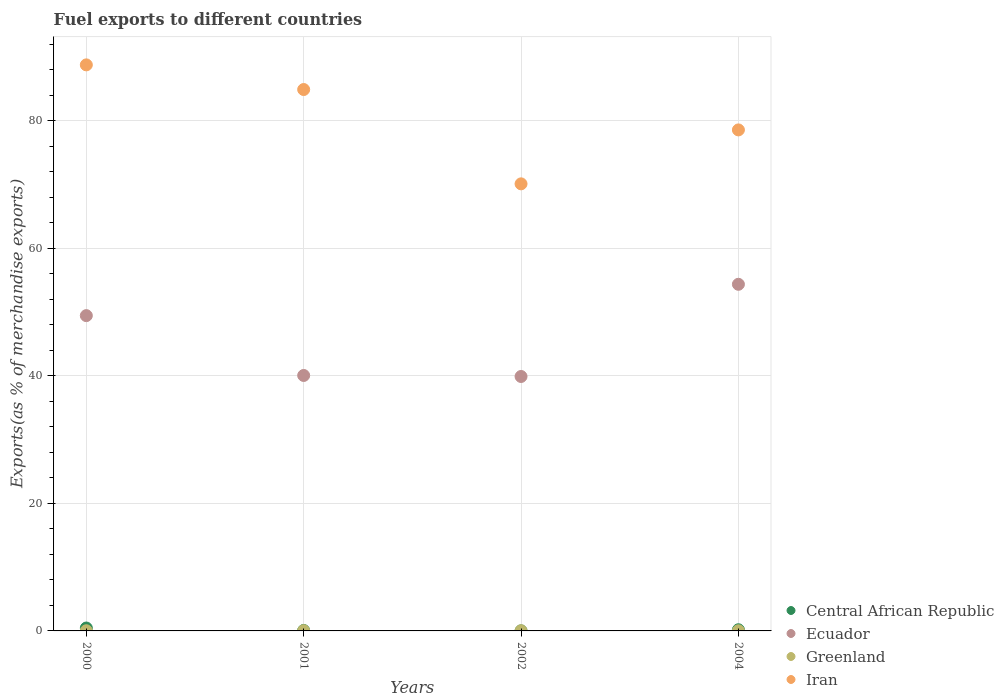How many different coloured dotlines are there?
Keep it short and to the point. 4. Is the number of dotlines equal to the number of legend labels?
Your response must be concise. Yes. What is the percentage of exports to different countries in Ecuador in 2004?
Make the answer very short. 54.34. Across all years, what is the maximum percentage of exports to different countries in Central African Republic?
Provide a succinct answer. 0.45. Across all years, what is the minimum percentage of exports to different countries in Ecuador?
Keep it short and to the point. 39.89. What is the total percentage of exports to different countries in Central African Republic in the graph?
Give a very brief answer. 0.72. What is the difference between the percentage of exports to different countries in Central African Republic in 2000 and that in 2002?
Make the answer very short. 0.45. What is the difference between the percentage of exports to different countries in Ecuador in 2002 and the percentage of exports to different countries in Iran in 2000?
Give a very brief answer. -48.85. What is the average percentage of exports to different countries in Ecuador per year?
Provide a succinct answer. 45.93. In the year 2000, what is the difference between the percentage of exports to different countries in Iran and percentage of exports to different countries in Central African Republic?
Keep it short and to the point. 88.29. What is the ratio of the percentage of exports to different countries in Ecuador in 2001 to that in 2004?
Give a very brief answer. 0.74. Is the percentage of exports to different countries in Iran in 2001 less than that in 2002?
Provide a succinct answer. No. Is the difference between the percentage of exports to different countries in Iran in 2000 and 2004 greater than the difference between the percentage of exports to different countries in Central African Republic in 2000 and 2004?
Your answer should be very brief. Yes. What is the difference between the highest and the second highest percentage of exports to different countries in Iran?
Offer a terse response. 3.86. What is the difference between the highest and the lowest percentage of exports to different countries in Ecuador?
Make the answer very short. 14.45. In how many years, is the percentage of exports to different countries in Central African Republic greater than the average percentage of exports to different countries in Central African Republic taken over all years?
Make the answer very short. 2. Is it the case that in every year, the sum of the percentage of exports to different countries in Iran and percentage of exports to different countries in Central African Republic  is greater than the sum of percentage of exports to different countries in Ecuador and percentage of exports to different countries in Greenland?
Your response must be concise. Yes. Does the percentage of exports to different countries in Ecuador monotonically increase over the years?
Provide a short and direct response. No. Is the percentage of exports to different countries in Central African Republic strictly less than the percentage of exports to different countries in Iran over the years?
Your answer should be compact. Yes. How many years are there in the graph?
Your answer should be very brief. 4. Does the graph contain any zero values?
Provide a short and direct response. No. Where does the legend appear in the graph?
Offer a very short reply. Bottom right. How many legend labels are there?
Provide a succinct answer. 4. What is the title of the graph?
Your response must be concise. Fuel exports to different countries. Does "Sub-Saharan Africa (developing only)" appear as one of the legend labels in the graph?
Your answer should be very brief. No. What is the label or title of the Y-axis?
Your response must be concise. Exports(as % of merchandise exports). What is the Exports(as % of merchandise exports) of Central African Republic in 2000?
Keep it short and to the point. 0.45. What is the Exports(as % of merchandise exports) in Ecuador in 2000?
Offer a very short reply. 49.43. What is the Exports(as % of merchandise exports) of Greenland in 2000?
Ensure brevity in your answer.  0.03. What is the Exports(as % of merchandise exports) of Iran in 2000?
Make the answer very short. 88.74. What is the Exports(as % of merchandise exports) of Central African Republic in 2001?
Offer a very short reply. 0.08. What is the Exports(as % of merchandise exports) in Ecuador in 2001?
Provide a succinct answer. 40.05. What is the Exports(as % of merchandise exports) in Greenland in 2001?
Give a very brief answer. 0.04. What is the Exports(as % of merchandise exports) of Iran in 2001?
Offer a terse response. 84.88. What is the Exports(as % of merchandise exports) of Central African Republic in 2002?
Offer a terse response. 0.01. What is the Exports(as % of merchandise exports) of Ecuador in 2002?
Your response must be concise. 39.89. What is the Exports(as % of merchandise exports) in Greenland in 2002?
Make the answer very short. 0.02. What is the Exports(as % of merchandise exports) of Iran in 2002?
Keep it short and to the point. 70.09. What is the Exports(as % of merchandise exports) in Central African Republic in 2004?
Give a very brief answer. 0.18. What is the Exports(as % of merchandise exports) in Ecuador in 2004?
Offer a terse response. 54.34. What is the Exports(as % of merchandise exports) in Greenland in 2004?
Your response must be concise. 0.02. What is the Exports(as % of merchandise exports) of Iran in 2004?
Provide a short and direct response. 78.55. Across all years, what is the maximum Exports(as % of merchandise exports) of Central African Republic?
Provide a short and direct response. 0.45. Across all years, what is the maximum Exports(as % of merchandise exports) of Ecuador?
Offer a very short reply. 54.34. Across all years, what is the maximum Exports(as % of merchandise exports) in Greenland?
Your answer should be compact. 0.04. Across all years, what is the maximum Exports(as % of merchandise exports) in Iran?
Your response must be concise. 88.74. Across all years, what is the minimum Exports(as % of merchandise exports) of Central African Republic?
Give a very brief answer. 0.01. Across all years, what is the minimum Exports(as % of merchandise exports) in Ecuador?
Keep it short and to the point. 39.89. Across all years, what is the minimum Exports(as % of merchandise exports) of Greenland?
Offer a terse response. 0.02. Across all years, what is the minimum Exports(as % of merchandise exports) of Iran?
Offer a very short reply. 70.09. What is the total Exports(as % of merchandise exports) in Central African Republic in the graph?
Offer a terse response. 0.72. What is the total Exports(as % of merchandise exports) in Ecuador in the graph?
Your answer should be very brief. 183.71. What is the total Exports(as % of merchandise exports) in Greenland in the graph?
Offer a very short reply. 0.11. What is the total Exports(as % of merchandise exports) in Iran in the graph?
Your answer should be compact. 322.26. What is the difference between the Exports(as % of merchandise exports) of Central African Republic in 2000 and that in 2001?
Provide a short and direct response. 0.38. What is the difference between the Exports(as % of merchandise exports) of Ecuador in 2000 and that in 2001?
Offer a terse response. 9.38. What is the difference between the Exports(as % of merchandise exports) in Greenland in 2000 and that in 2001?
Offer a very short reply. -0.01. What is the difference between the Exports(as % of merchandise exports) in Iran in 2000 and that in 2001?
Ensure brevity in your answer.  3.86. What is the difference between the Exports(as % of merchandise exports) in Central African Republic in 2000 and that in 2002?
Your response must be concise. 0.45. What is the difference between the Exports(as % of merchandise exports) in Ecuador in 2000 and that in 2002?
Provide a short and direct response. 9.54. What is the difference between the Exports(as % of merchandise exports) of Greenland in 2000 and that in 2002?
Give a very brief answer. 0. What is the difference between the Exports(as % of merchandise exports) of Iran in 2000 and that in 2002?
Give a very brief answer. 18.65. What is the difference between the Exports(as % of merchandise exports) of Central African Republic in 2000 and that in 2004?
Keep it short and to the point. 0.27. What is the difference between the Exports(as % of merchandise exports) in Ecuador in 2000 and that in 2004?
Make the answer very short. -4.91. What is the difference between the Exports(as % of merchandise exports) of Greenland in 2000 and that in 2004?
Provide a short and direct response. 0. What is the difference between the Exports(as % of merchandise exports) in Iran in 2000 and that in 2004?
Your response must be concise. 10.2. What is the difference between the Exports(as % of merchandise exports) of Central African Republic in 2001 and that in 2002?
Provide a succinct answer. 0.07. What is the difference between the Exports(as % of merchandise exports) of Ecuador in 2001 and that in 2002?
Give a very brief answer. 0.16. What is the difference between the Exports(as % of merchandise exports) in Greenland in 2001 and that in 2002?
Provide a short and direct response. 0.01. What is the difference between the Exports(as % of merchandise exports) of Iran in 2001 and that in 2002?
Your response must be concise. 14.79. What is the difference between the Exports(as % of merchandise exports) of Central African Republic in 2001 and that in 2004?
Make the answer very short. -0.11. What is the difference between the Exports(as % of merchandise exports) of Ecuador in 2001 and that in 2004?
Provide a succinct answer. -14.29. What is the difference between the Exports(as % of merchandise exports) in Greenland in 2001 and that in 2004?
Provide a short and direct response. 0.02. What is the difference between the Exports(as % of merchandise exports) of Iran in 2001 and that in 2004?
Offer a very short reply. 6.33. What is the difference between the Exports(as % of merchandise exports) of Central African Republic in 2002 and that in 2004?
Keep it short and to the point. -0.17. What is the difference between the Exports(as % of merchandise exports) in Ecuador in 2002 and that in 2004?
Provide a short and direct response. -14.45. What is the difference between the Exports(as % of merchandise exports) of Greenland in 2002 and that in 2004?
Make the answer very short. 0. What is the difference between the Exports(as % of merchandise exports) in Iran in 2002 and that in 2004?
Make the answer very short. -8.46. What is the difference between the Exports(as % of merchandise exports) of Central African Republic in 2000 and the Exports(as % of merchandise exports) of Ecuador in 2001?
Keep it short and to the point. -39.59. What is the difference between the Exports(as % of merchandise exports) in Central African Republic in 2000 and the Exports(as % of merchandise exports) in Greenland in 2001?
Provide a succinct answer. 0.42. What is the difference between the Exports(as % of merchandise exports) in Central African Republic in 2000 and the Exports(as % of merchandise exports) in Iran in 2001?
Provide a short and direct response. -84.42. What is the difference between the Exports(as % of merchandise exports) in Ecuador in 2000 and the Exports(as % of merchandise exports) in Greenland in 2001?
Provide a short and direct response. 49.39. What is the difference between the Exports(as % of merchandise exports) of Ecuador in 2000 and the Exports(as % of merchandise exports) of Iran in 2001?
Offer a terse response. -35.45. What is the difference between the Exports(as % of merchandise exports) of Greenland in 2000 and the Exports(as % of merchandise exports) of Iran in 2001?
Provide a succinct answer. -84.85. What is the difference between the Exports(as % of merchandise exports) in Central African Republic in 2000 and the Exports(as % of merchandise exports) in Ecuador in 2002?
Offer a terse response. -39.43. What is the difference between the Exports(as % of merchandise exports) of Central African Republic in 2000 and the Exports(as % of merchandise exports) of Greenland in 2002?
Ensure brevity in your answer.  0.43. What is the difference between the Exports(as % of merchandise exports) in Central African Republic in 2000 and the Exports(as % of merchandise exports) in Iran in 2002?
Ensure brevity in your answer.  -69.64. What is the difference between the Exports(as % of merchandise exports) in Ecuador in 2000 and the Exports(as % of merchandise exports) in Greenland in 2002?
Ensure brevity in your answer.  49.41. What is the difference between the Exports(as % of merchandise exports) in Ecuador in 2000 and the Exports(as % of merchandise exports) in Iran in 2002?
Your answer should be very brief. -20.66. What is the difference between the Exports(as % of merchandise exports) in Greenland in 2000 and the Exports(as % of merchandise exports) in Iran in 2002?
Offer a terse response. -70.06. What is the difference between the Exports(as % of merchandise exports) of Central African Republic in 2000 and the Exports(as % of merchandise exports) of Ecuador in 2004?
Give a very brief answer. -53.89. What is the difference between the Exports(as % of merchandise exports) in Central African Republic in 2000 and the Exports(as % of merchandise exports) in Greenland in 2004?
Provide a short and direct response. 0.43. What is the difference between the Exports(as % of merchandise exports) of Central African Republic in 2000 and the Exports(as % of merchandise exports) of Iran in 2004?
Your answer should be very brief. -78.09. What is the difference between the Exports(as % of merchandise exports) of Ecuador in 2000 and the Exports(as % of merchandise exports) of Greenland in 2004?
Your response must be concise. 49.41. What is the difference between the Exports(as % of merchandise exports) in Ecuador in 2000 and the Exports(as % of merchandise exports) in Iran in 2004?
Your response must be concise. -29.12. What is the difference between the Exports(as % of merchandise exports) of Greenland in 2000 and the Exports(as % of merchandise exports) of Iran in 2004?
Keep it short and to the point. -78.52. What is the difference between the Exports(as % of merchandise exports) in Central African Republic in 2001 and the Exports(as % of merchandise exports) in Ecuador in 2002?
Make the answer very short. -39.81. What is the difference between the Exports(as % of merchandise exports) of Central African Republic in 2001 and the Exports(as % of merchandise exports) of Greenland in 2002?
Your response must be concise. 0.05. What is the difference between the Exports(as % of merchandise exports) in Central African Republic in 2001 and the Exports(as % of merchandise exports) in Iran in 2002?
Your response must be concise. -70.02. What is the difference between the Exports(as % of merchandise exports) of Ecuador in 2001 and the Exports(as % of merchandise exports) of Greenland in 2002?
Give a very brief answer. 40.02. What is the difference between the Exports(as % of merchandise exports) in Ecuador in 2001 and the Exports(as % of merchandise exports) in Iran in 2002?
Make the answer very short. -30.04. What is the difference between the Exports(as % of merchandise exports) in Greenland in 2001 and the Exports(as % of merchandise exports) in Iran in 2002?
Keep it short and to the point. -70.05. What is the difference between the Exports(as % of merchandise exports) in Central African Republic in 2001 and the Exports(as % of merchandise exports) in Ecuador in 2004?
Your answer should be very brief. -54.27. What is the difference between the Exports(as % of merchandise exports) of Central African Republic in 2001 and the Exports(as % of merchandise exports) of Greenland in 2004?
Provide a succinct answer. 0.05. What is the difference between the Exports(as % of merchandise exports) of Central African Republic in 2001 and the Exports(as % of merchandise exports) of Iran in 2004?
Give a very brief answer. -78.47. What is the difference between the Exports(as % of merchandise exports) in Ecuador in 2001 and the Exports(as % of merchandise exports) in Greenland in 2004?
Provide a succinct answer. 40.03. What is the difference between the Exports(as % of merchandise exports) of Ecuador in 2001 and the Exports(as % of merchandise exports) of Iran in 2004?
Your answer should be compact. -38.5. What is the difference between the Exports(as % of merchandise exports) in Greenland in 2001 and the Exports(as % of merchandise exports) in Iran in 2004?
Give a very brief answer. -78.51. What is the difference between the Exports(as % of merchandise exports) of Central African Republic in 2002 and the Exports(as % of merchandise exports) of Ecuador in 2004?
Keep it short and to the point. -54.33. What is the difference between the Exports(as % of merchandise exports) in Central African Republic in 2002 and the Exports(as % of merchandise exports) in Greenland in 2004?
Keep it short and to the point. -0.01. What is the difference between the Exports(as % of merchandise exports) in Central African Republic in 2002 and the Exports(as % of merchandise exports) in Iran in 2004?
Your response must be concise. -78.54. What is the difference between the Exports(as % of merchandise exports) of Ecuador in 2002 and the Exports(as % of merchandise exports) of Greenland in 2004?
Give a very brief answer. 39.87. What is the difference between the Exports(as % of merchandise exports) in Ecuador in 2002 and the Exports(as % of merchandise exports) in Iran in 2004?
Ensure brevity in your answer.  -38.66. What is the difference between the Exports(as % of merchandise exports) of Greenland in 2002 and the Exports(as % of merchandise exports) of Iran in 2004?
Make the answer very short. -78.52. What is the average Exports(as % of merchandise exports) in Central African Republic per year?
Ensure brevity in your answer.  0.18. What is the average Exports(as % of merchandise exports) in Ecuador per year?
Your response must be concise. 45.93. What is the average Exports(as % of merchandise exports) of Greenland per year?
Provide a succinct answer. 0.03. What is the average Exports(as % of merchandise exports) of Iran per year?
Your answer should be very brief. 80.56. In the year 2000, what is the difference between the Exports(as % of merchandise exports) in Central African Republic and Exports(as % of merchandise exports) in Ecuador?
Provide a succinct answer. -48.98. In the year 2000, what is the difference between the Exports(as % of merchandise exports) in Central African Republic and Exports(as % of merchandise exports) in Greenland?
Offer a terse response. 0.43. In the year 2000, what is the difference between the Exports(as % of merchandise exports) in Central African Republic and Exports(as % of merchandise exports) in Iran?
Offer a terse response. -88.29. In the year 2000, what is the difference between the Exports(as % of merchandise exports) of Ecuador and Exports(as % of merchandise exports) of Greenland?
Offer a terse response. 49.4. In the year 2000, what is the difference between the Exports(as % of merchandise exports) of Ecuador and Exports(as % of merchandise exports) of Iran?
Keep it short and to the point. -39.31. In the year 2000, what is the difference between the Exports(as % of merchandise exports) of Greenland and Exports(as % of merchandise exports) of Iran?
Your response must be concise. -88.72. In the year 2001, what is the difference between the Exports(as % of merchandise exports) of Central African Republic and Exports(as % of merchandise exports) of Ecuador?
Give a very brief answer. -39.97. In the year 2001, what is the difference between the Exports(as % of merchandise exports) of Central African Republic and Exports(as % of merchandise exports) of Greenland?
Your answer should be very brief. 0.04. In the year 2001, what is the difference between the Exports(as % of merchandise exports) of Central African Republic and Exports(as % of merchandise exports) of Iran?
Ensure brevity in your answer.  -84.8. In the year 2001, what is the difference between the Exports(as % of merchandise exports) in Ecuador and Exports(as % of merchandise exports) in Greenland?
Provide a short and direct response. 40.01. In the year 2001, what is the difference between the Exports(as % of merchandise exports) in Ecuador and Exports(as % of merchandise exports) in Iran?
Your answer should be very brief. -44.83. In the year 2001, what is the difference between the Exports(as % of merchandise exports) in Greenland and Exports(as % of merchandise exports) in Iran?
Your response must be concise. -84.84. In the year 2002, what is the difference between the Exports(as % of merchandise exports) of Central African Republic and Exports(as % of merchandise exports) of Ecuador?
Ensure brevity in your answer.  -39.88. In the year 2002, what is the difference between the Exports(as % of merchandise exports) in Central African Republic and Exports(as % of merchandise exports) in Greenland?
Offer a very short reply. -0.02. In the year 2002, what is the difference between the Exports(as % of merchandise exports) of Central African Republic and Exports(as % of merchandise exports) of Iran?
Offer a very short reply. -70.08. In the year 2002, what is the difference between the Exports(as % of merchandise exports) in Ecuador and Exports(as % of merchandise exports) in Greenland?
Provide a succinct answer. 39.86. In the year 2002, what is the difference between the Exports(as % of merchandise exports) in Ecuador and Exports(as % of merchandise exports) in Iran?
Ensure brevity in your answer.  -30.2. In the year 2002, what is the difference between the Exports(as % of merchandise exports) in Greenland and Exports(as % of merchandise exports) in Iran?
Your answer should be very brief. -70.07. In the year 2004, what is the difference between the Exports(as % of merchandise exports) of Central African Republic and Exports(as % of merchandise exports) of Ecuador?
Give a very brief answer. -54.16. In the year 2004, what is the difference between the Exports(as % of merchandise exports) in Central African Republic and Exports(as % of merchandise exports) in Greenland?
Keep it short and to the point. 0.16. In the year 2004, what is the difference between the Exports(as % of merchandise exports) in Central African Republic and Exports(as % of merchandise exports) in Iran?
Keep it short and to the point. -78.36. In the year 2004, what is the difference between the Exports(as % of merchandise exports) of Ecuador and Exports(as % of merchandise exports) of Greenland?
Your response must be concise. 54.32. In the year 2004, what is the difference between the Exports(as % of merchandise exports) of Ecuador and Exports(as % of merchandise exports) of Iran?
Your response must be concise. -24.2. In the year 2004, what is the difference between the Exports(as % of merchandise exports) in Greenland and Exports(as % of merchandise exports) in Iran?
Your answer should be compact. -78.52. What is the ratio of the Exports(as % of merchandise exports) in Central African Republic in 2000 to that in 2001?
Provide a succinct answer. 6.02. What is the ratio of the Exports(as % of merchandise exports) of Ecuador in 2000 to that in 2001?
Provide a short and direct response. 1.23. What is the ratio of the Exports(as % of merchandise exports) in Greenland in 2000 to that in 2001?
Your response must be concise. 0.71. What is the ratio of the Exports(as % of merchandise exports) in Iran in 2000 to that in 2001?
Your answer should be very brief. 1.05. What is the ratio of the Exports(as % of merchandise exports) of Central African Republic in 2000 to that in 2002?
Offer a very short reply. 47.43. What is the ratio of the Exports(as % of merchandise exports) in Ecuador in 2000 to that in 2002?
Give a very brief answer. 1.24. What is the ratio of the Exports(as % of merchandise exports) in Greenland in 2000 to that in 2002?
Ensure brevity in your answer.  1.09. What is the ratio of the Exports(as % of merchandise exports) in Iran in 2000 to that in 2002?
Keep it short and to the point. 1.27. What is the ratio of the Exports(as % of merchandise exports) in Central African Republic in 2000 to that in 2004?
Provide a short and direct response. 2.48. What is the ratio of the Exports(as % of merchandise exports) of Ecuador in 2000 to that in 2004?
Offer a terse response. 0.91. What is the ratio of the Exports(as % of merchandise exports) in Greenland in 2000 to that in 2004?
Keep it short and to the point. 1.19. What is the ratio of the Exports(as % of merchandise exports) of Iran in 2000 to that in 2004?
Offer a terse response. 1.13. What is the ratio of the Exports(as % of merchandise exports) of Central African Republic in 2001 to that in 2002?
Your answer should be very brief. 7.88. What is the ratio of the Exports(as % of merchandise exports) of Ecuador in 2001 to that in 2002?
Your answer should be very brief. 1. What is the ratio of the Exports(as % of merchandise exports) in Greenland in 2001 to that in 2002?
Offer a terse response. 1.53. What is the ratio of the Exports(as % of merchandise exports) of Iran in 2001 to that in 2002?
Offer a very short reply. 1.21. What is the ratio of the Exports(as % of merchandise exports) of Central African Republic in 2001 to that in 2004?
Give a very brief answer. 0.41. What is the ratio of the Exports(as % of merchandise exports) in Ecuador in 2001 to that in 2004?
Offer a terse response. 0.74. What is the ratio of the Exports(as % of merchandise exports) in Greenland in 2001 to that in 2004?
Your answer should be very brief. 1.69. What is the ratio of the Exports(as % of merchandise exports) in Iran in 2001 to that in 2004?
Offer a very short reply. 1.08. What is the ratio of the Exports(as % of merchandise exports) of Central African Republic in 2002 to that in 2004?
Offer a very short reply. 0.05. What is the ratio of the Exports(as % of merchandise exports) in Ecuador in 2002 to that in 2004?
Offer a very short reply. 0.73. What is the ratio of the Exports(as % of merchandise exports) of Greenland in 2002 to that in 2004?
Provide a short and direct response. 1.1. What is the ratio of the Exports(as % of merchandise exports) of Iran in 2002 to that in 2004?
Offer a very short reply. 0.89. What is the difference between the highest and the second highest Exports(as % of merchandise exports) in Central African Republic?
Your answer should be compact. 0.27. What is the difference between the highest and the second highest Exports(as % of merchandise exports) of Ecuador?
Offer a terse response. 4.91. What is the difference between the highest and the second highest Exports(as % of merchandise exports) in Greenland?
Offer a terse response. 0.01. What is the difference between the highest and the second highest Exports(as % of merchandise exports) in Iran?
Offer a very short reply. 3.86. What is the difference between the highest and the lowest Exports(as % of merchandise exports) in Central African Republic?
Make the answer very short. 0.45. What is the difference between the highest and the lowest Exports(as % of merchandise exports) of Ecuador?
Your answer should be very brief. 14.45. What is the difference between the highest and the lowest Exports(as % of merchandise exports) of Greenland?
Provide a succinct answer. 0.02. What is the difference between the highest and the lowest Exports(as % of merchandise exports) in Iran?
Keep it short and to the point. 18.65. 